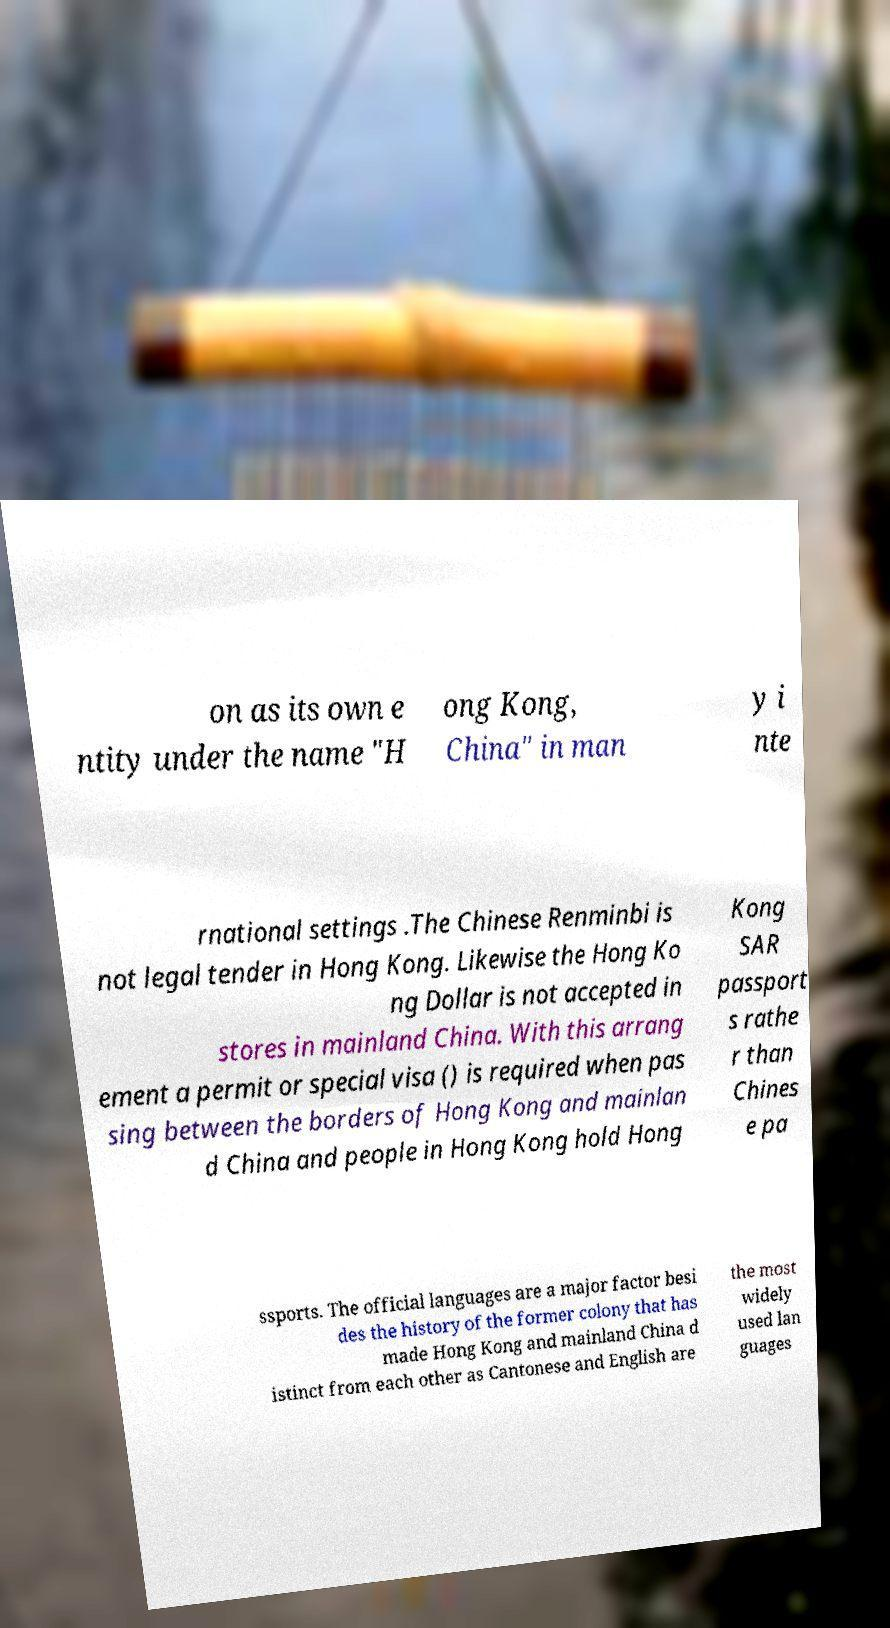Can you read and provide the text displayed in the image?This photo seems to have some interesting text. Can you extract and type it out for me? on as its own e ntity under the name "H ong Kong, China" in man y i nte rnational settings .The Chinese Renminbi is not legal tender in Hong Kong. Likewise the Hong Ko ng Dollar is not accepted in stores in mainland China. With this arrang ement a permit or special visa () is required when pas sing between the borders of Hong Kong and mainlan d China and people in Hong Kong hold Hong Kong SAR passport s rathe r than Chines e pa ssports. The official languages are a major factor besi des the history of the former colony that has made Hong Kong and mainland China d istinct from each other as Cantonese and English are the most widely used lan guages 